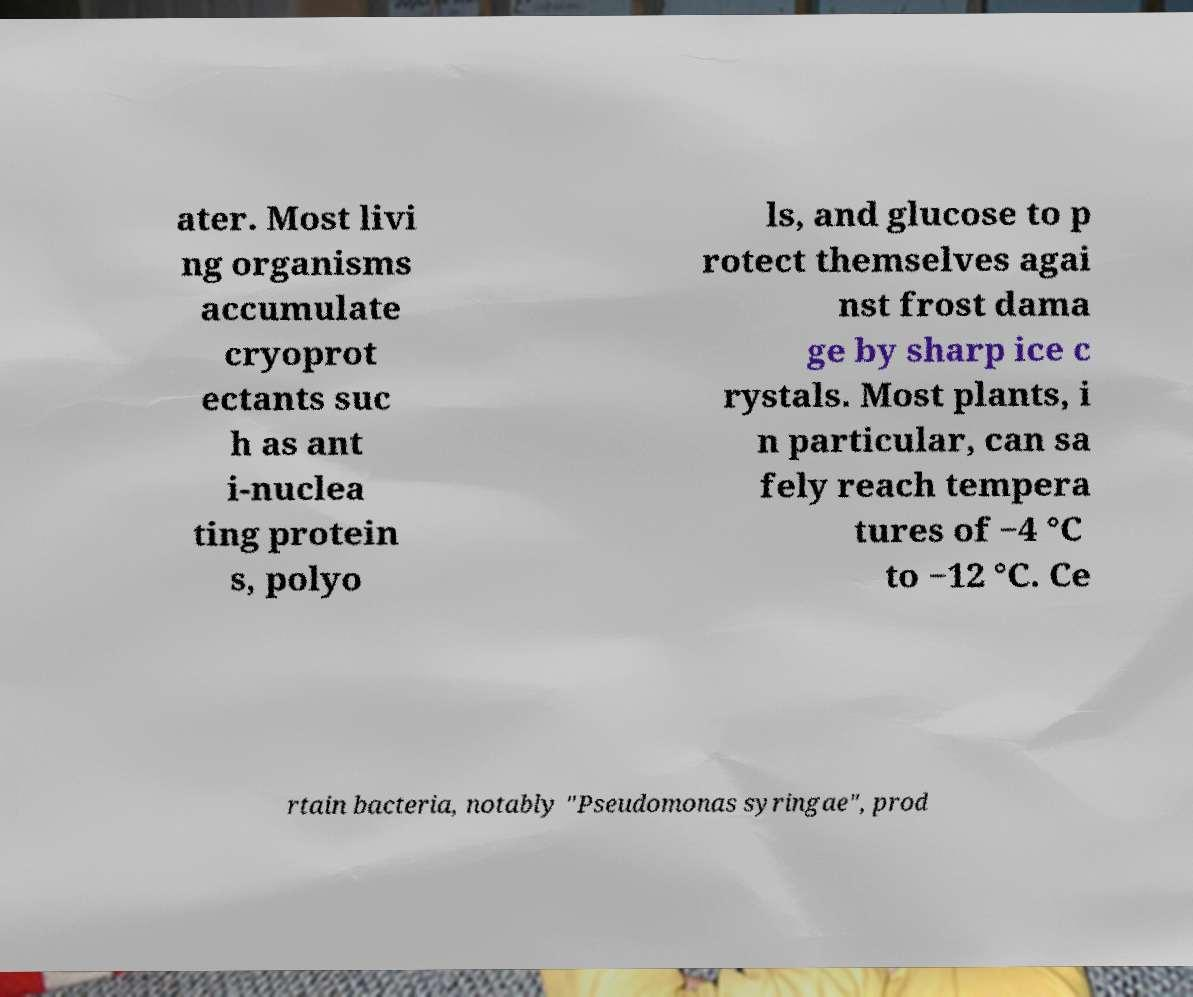There's text embedded in this image that I need extracted. Can you transcribe it verbatim? ater. Most livi ng organisms accumulate cryoprot ectants suc h as ant i-nuclea ting protein s, polyo ls, and glucose to p rotect themselves agai nst frost dama ge by sharp ice c rystals. Most plants, i n particular, can sa fely reach tempera tures of −4 °C to −12 °C. Ce rtain bacteria, notably "Pseudomonas syringae", prod 